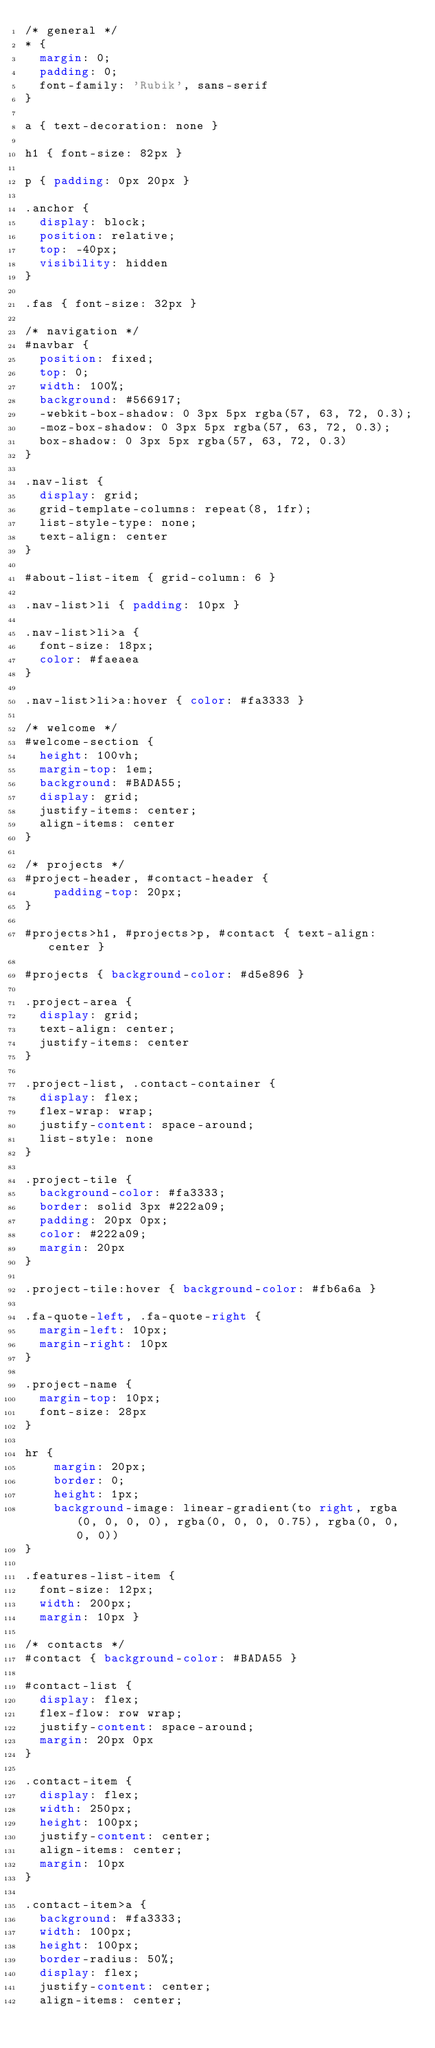<code> <loc_0><loc_0><loc_500><loc_500><_CSS_>/* general */
* {
  margin: 0;
  padding: 0;
  font-family: 'Rubik', sans-serif
}

a { text-decoration: none }

h1 { font-size: 82px }

p { padding: 0px 20px }

.anchor {
  display: block; 
  position: relative; 
  top: -40px;
  visibility: hidden
}

.fas { font-size: 32px }

/* navigation */
#navbar {
  position: fixed;
  top: 0;
  width: 100%;
  background: #566917;
  -webkit-box-shadow: 0 3px 5px rgba(57, 63, 72, 0.3);
  -moz-box-shadow: 0 3px 5px rgba(57, 63, 72, 0.3);
  box-shadow: 0 3px 5px rgba(57, 63, 72, 0.3)
}

.nav-list {
  display: grid;
  grid-template-columns: repeat(8, 1fr);
  list-style-type: none;
  text-align: center
}

#about-list-item { grid-column: 6 }

.nav-list>li { padding: 10px }

.nav-list>li>a {
  font-size: 18px;
  color: #faeaea
}

.nav-list>li>a:hover { color: #fa3333 }

/* welcome */
#welcome-section {
  height: 100vh;
  margin-top: 1em;
  background: #BADA55;
  display: grid;
  justify-items: center;
  align-items: center
}

/* projects */
#project-header, #contact-header {
    padding-top: 20px;
}

#projects>h1, #projects>p, #contact { text-align: center }

#projects { background-color: #d5e896 }

.project-area {
  display: grid;
  text-align: center;
  justify-items: center
}

.project-list, .contact-container {
  display: flex;
  flex-wrap: wrap;
  justify-content: space-around;
  list-style: none
}

.project-tile {
  background-color: #fa3333;
  border: solid 3px #222a09;
  padding: 20px 0px;
  color: #222a09;
  margin: 20px
}

.project-tile:hover { background-color: #fb6a6a }

.fa-quote-left, .fa-quote-right {
  margin-left: 10px;
  margin-right: 10px
}

.project-name {
  margin-top: 10px;
  font-size: 28px
}

hr {
    margin: 20px;
    border: 0;
    height: 1px;
    background-image: linear-gradient(to right, rgba(0, 0, 0, 0), rgba(0, 0, 0, 0.75), rgba(0, 0, 0, 0))
}

.features-list-item {
  font-size: 12px;
  width: 200px;
  margin: 10px }

/* contacts */
#contact { background-color: #BADA55 }

#contact-list {
  display: flex;
  flex-flow: row wrap;
  justify-content: space-around;
  margin: 20px 0px
}

.contact-item {
  display: flex;
  width: 250px;
  height: 100px;
  justify-content: center;
  align-items: center;
  margin: 10px
}

.contact-item>a {
  background: #fa3333;
  width: 100px;
  height: 100px;
  border-radius: 50%;
  display: flex;
  justify-content: center;
  align-items: center;</code> 